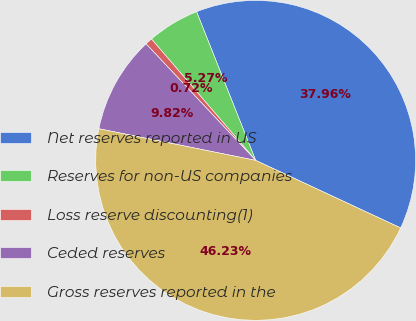<chart> <loc_0><loc_0><loc_500><loc_500><pie_chart><fcel>Net reserves reported in US<fcel>Reserves for non-US companies<fcel>Loss reserve discounting(1)<fcel>Ceded reserves<fcel>Gross reserves reported in the<nl><fcel>37.96%<fcel>5.27%<fcel>0.72%<fcel>9.82%<fcel>46.23%<nl></chart> 